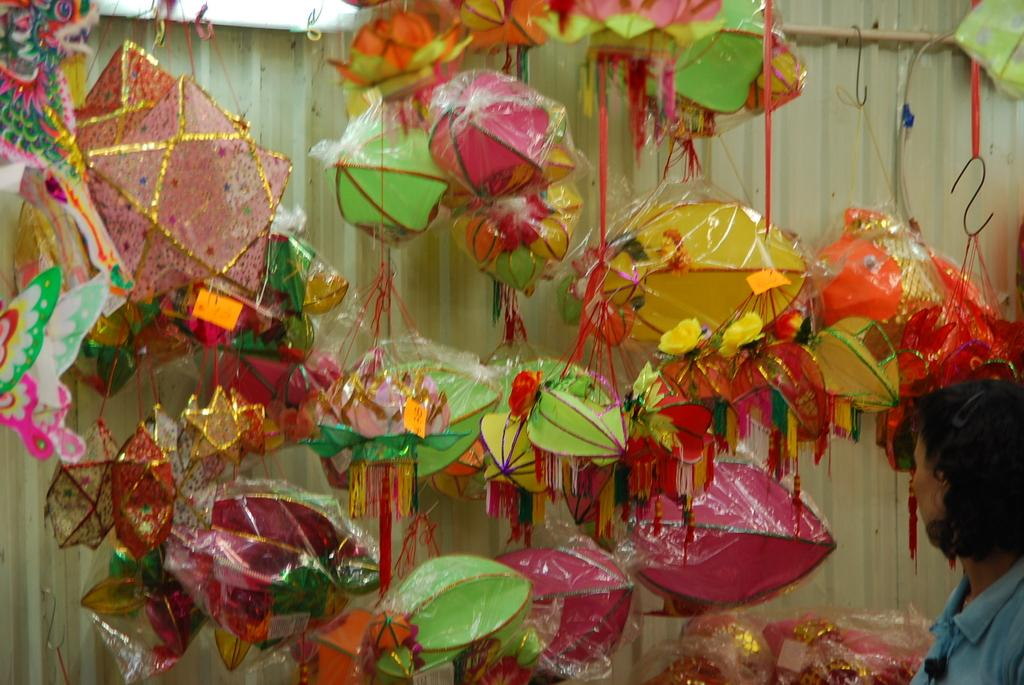What objects can be seen in the image? There are lanterns in the image. How are the lanterns positioned? The lanterns are covered and hanging from hooks. Who is present in the image? There is a woman standing in the image. What is the woman doing? The woman is looking at the lanterns. Can you tell me how the leather is being used by the woman in the image? There is no leather present in the image, so it cannot be used by the woman. 